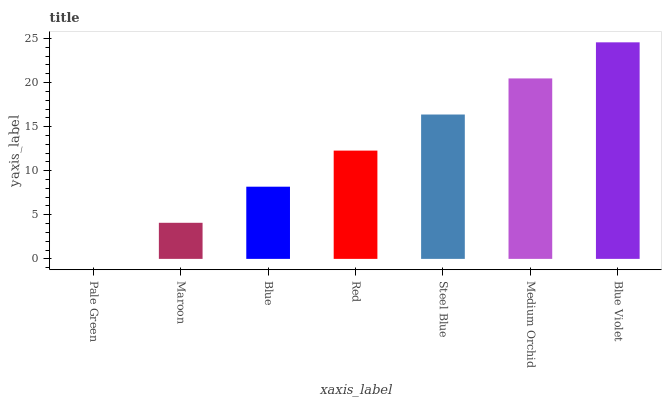Is Pale Green the minimum?
Answer yes or no. Yes. Is Blue Violet the maximum?
Answer yes or no. Yes. Is Maroon the minimum?
Answer yes or no. No. Is Maroon the maximum?
Answer yes or no. No. Is Maroon greater than Pale Green?
Answer yes or no. Yes. Is Pale Green less than Maroon?
Answer yes or no. Yes. Is Pale Green greater than Maroon?
Answer yes or no. No. Is Maroon less than Pale Green?
Answer yes or no. No. Is Red the high median?
Answer yes or no. Yes. Is Red the low median?
Answer yes or no. Yes. Is Maroon the high median?
Answer yes or no. No. Is Blue Violet the low median?
Answer yes or no. No. 